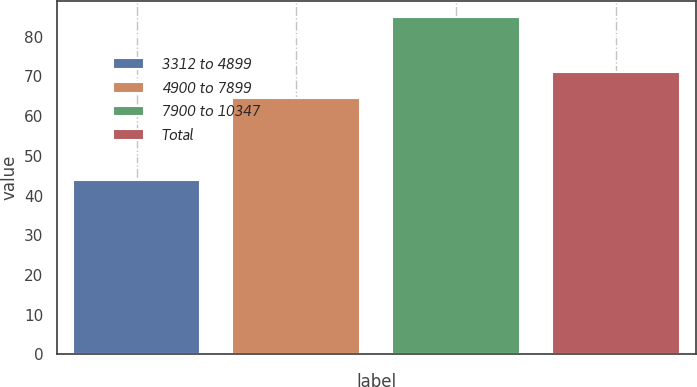<chart> <loc_0><loc_0><loc_500><loc_500><bar_chart><fcel>3312 to 4899<fcel>4900 to 7899<fcel>7900 to 10347<fcel>Total<nl><fcel>43.85<fcel>64.59<fcel>84.86<fcel>71.08<nl></chart> 